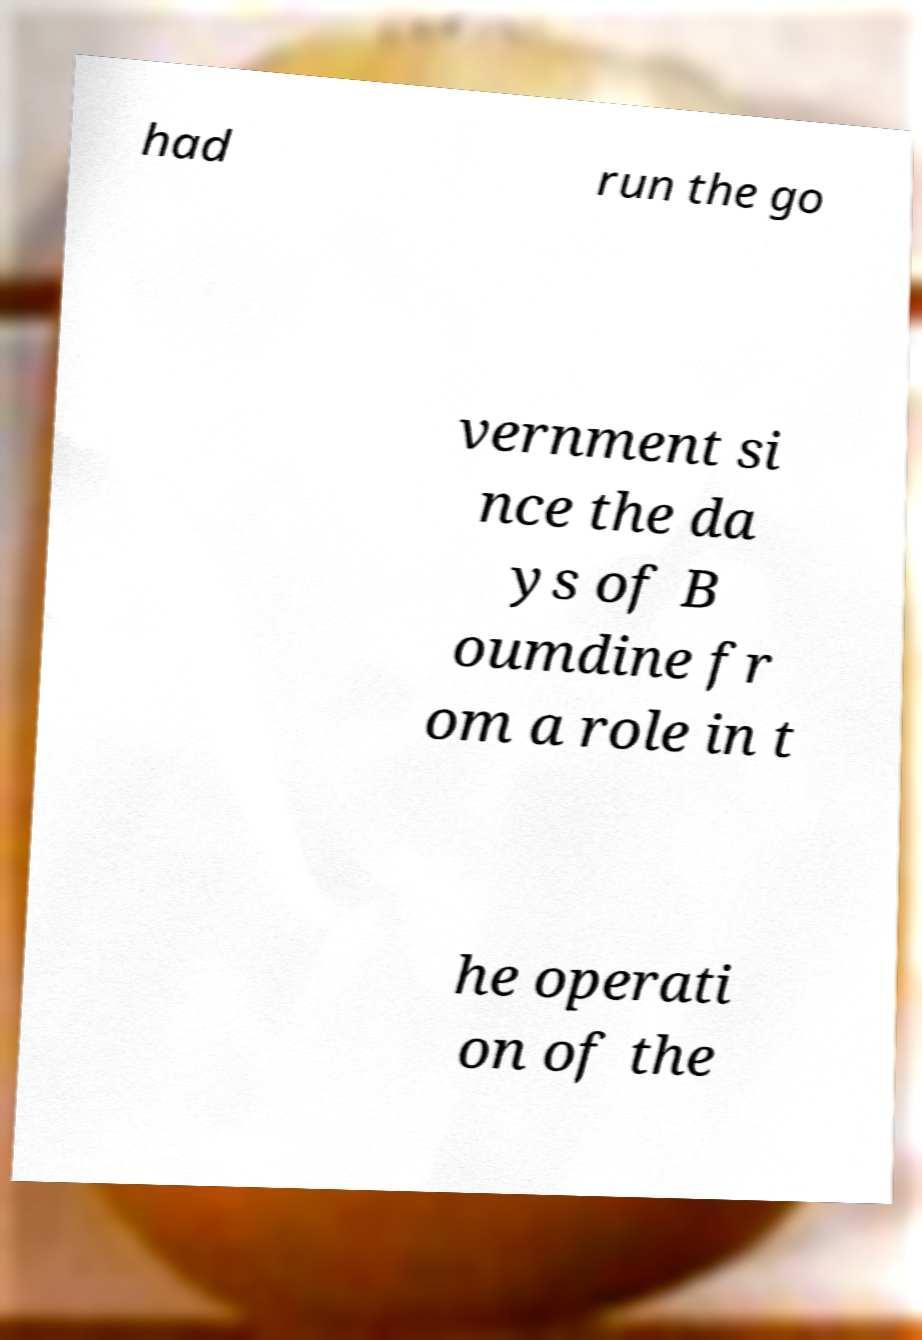I need the written content from this picture converted into text. Can you do that? had run the go vernment si nce the da ys of B oumdine fr om a role in t he operati on of the 